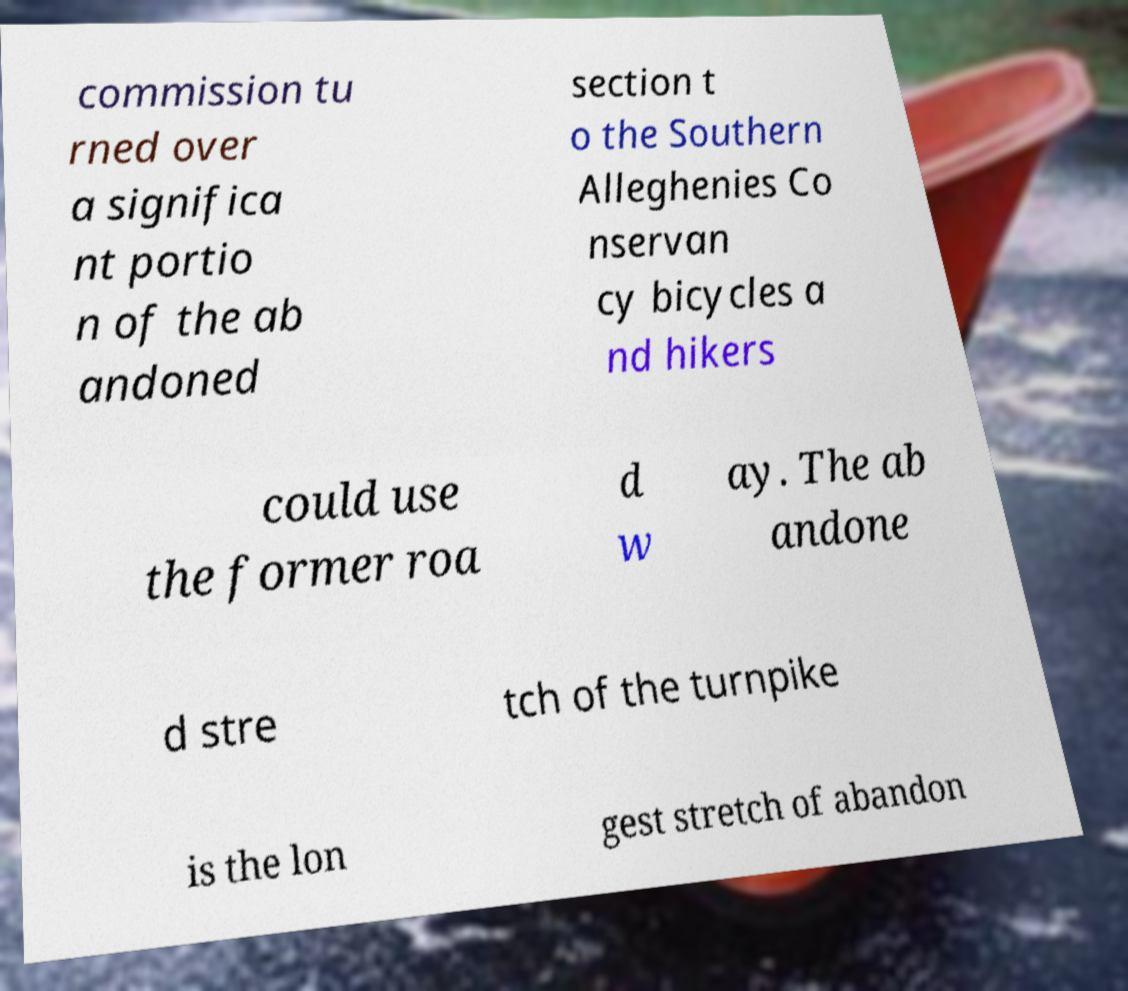There's text embedded in this image that I need extracted. Can you transcribe it verbatim? commission tu rned over a significa nt portio n of the ab andoned section t o the Southern Alleghenies Co nservan cy bicycles a nd hikers could use the former roa d w ay. The ab andone d stre tch of the turnpike is the lon gest stretch of abandon 